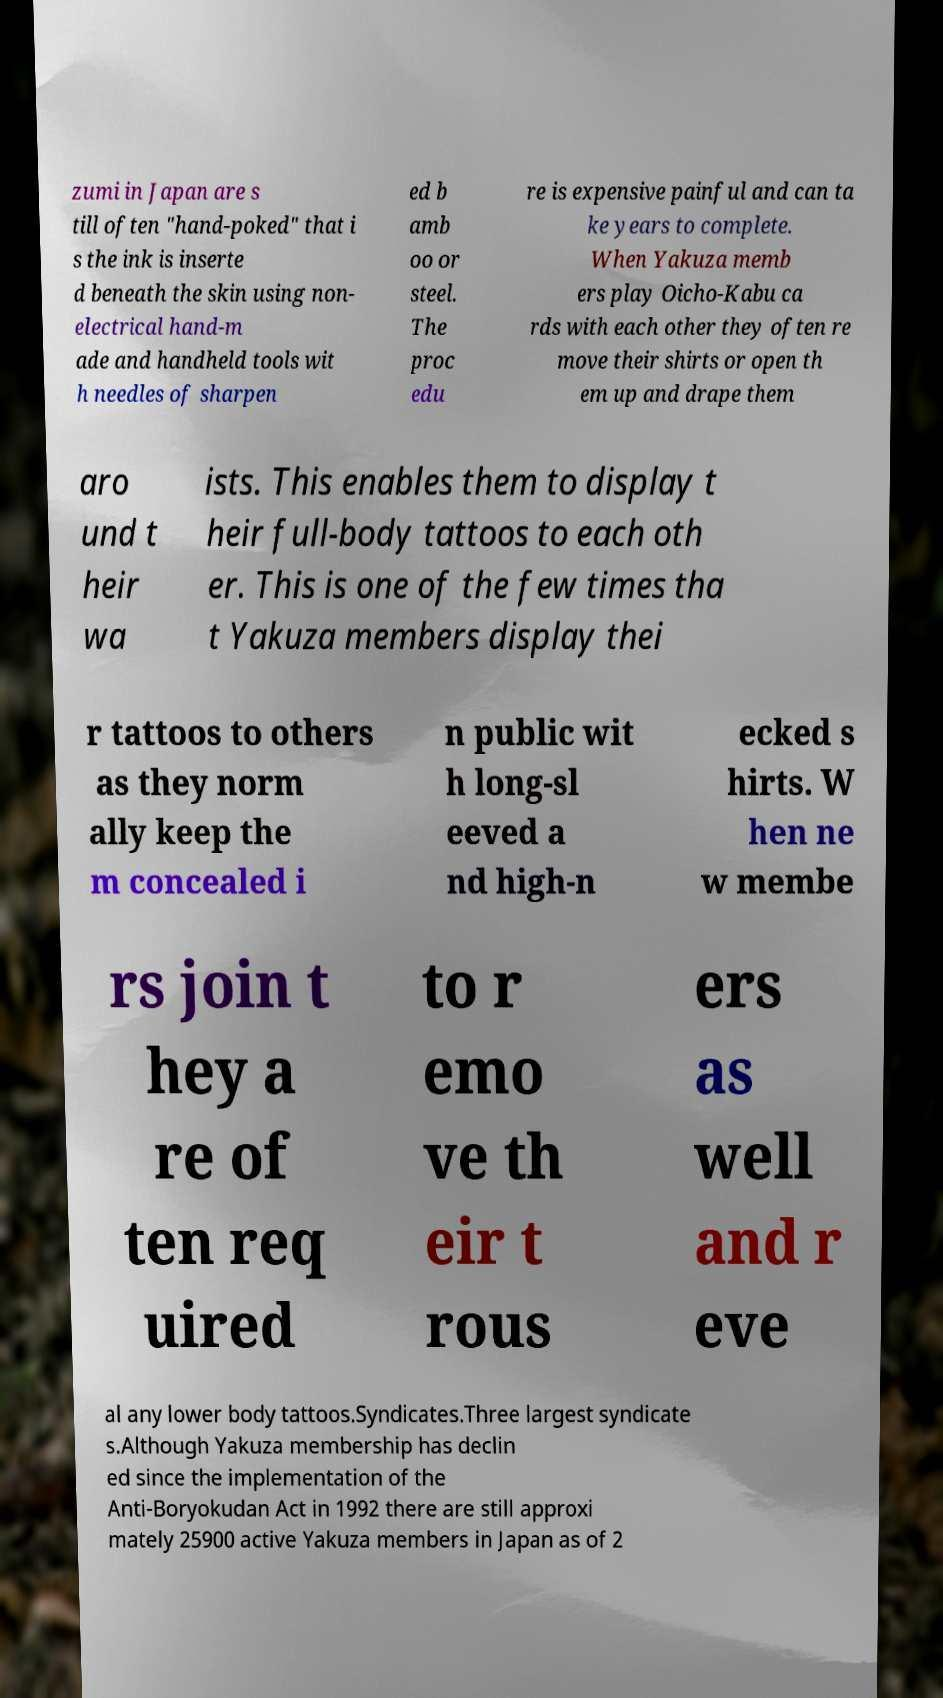There's text embedded in this image that I need extracted. Can you transcribe it verbatim? zumi in Japan are s till often "hand-poked" that i s the ink is inserte d beneath the skin using non- electrical hand-m ade and handheld tools wit h needles of sharpen ed b amb oo or steel. The proc edu re is expensive painful and can ta ke years to complete. When Yakuza memb ers play Oicho-Kabu ca rds with each other they often re move their shirts or open th em up and drape them aro und t heir wa ists. This enables them to display t heir full-body tattoos to each oth er. This is one of the few times tha t Yakuza members display thei r tattoos to others as they norm ally keep the m concealed i n public wit h long-sl eeved a nd high-n ecked s hirts. W hen ne w membe rs join t hey a re of ten req uired to r emo ve th eir t rous ers as well and r eve al any lower body tattoos.Syndicates.Three largest syndicate s.Although Yakuza membership has declin ed since the implementation of the Anti-Boryokudan Act in 1992 there are still approxi mately 25900 active Yakuza members in Japan as of 2 